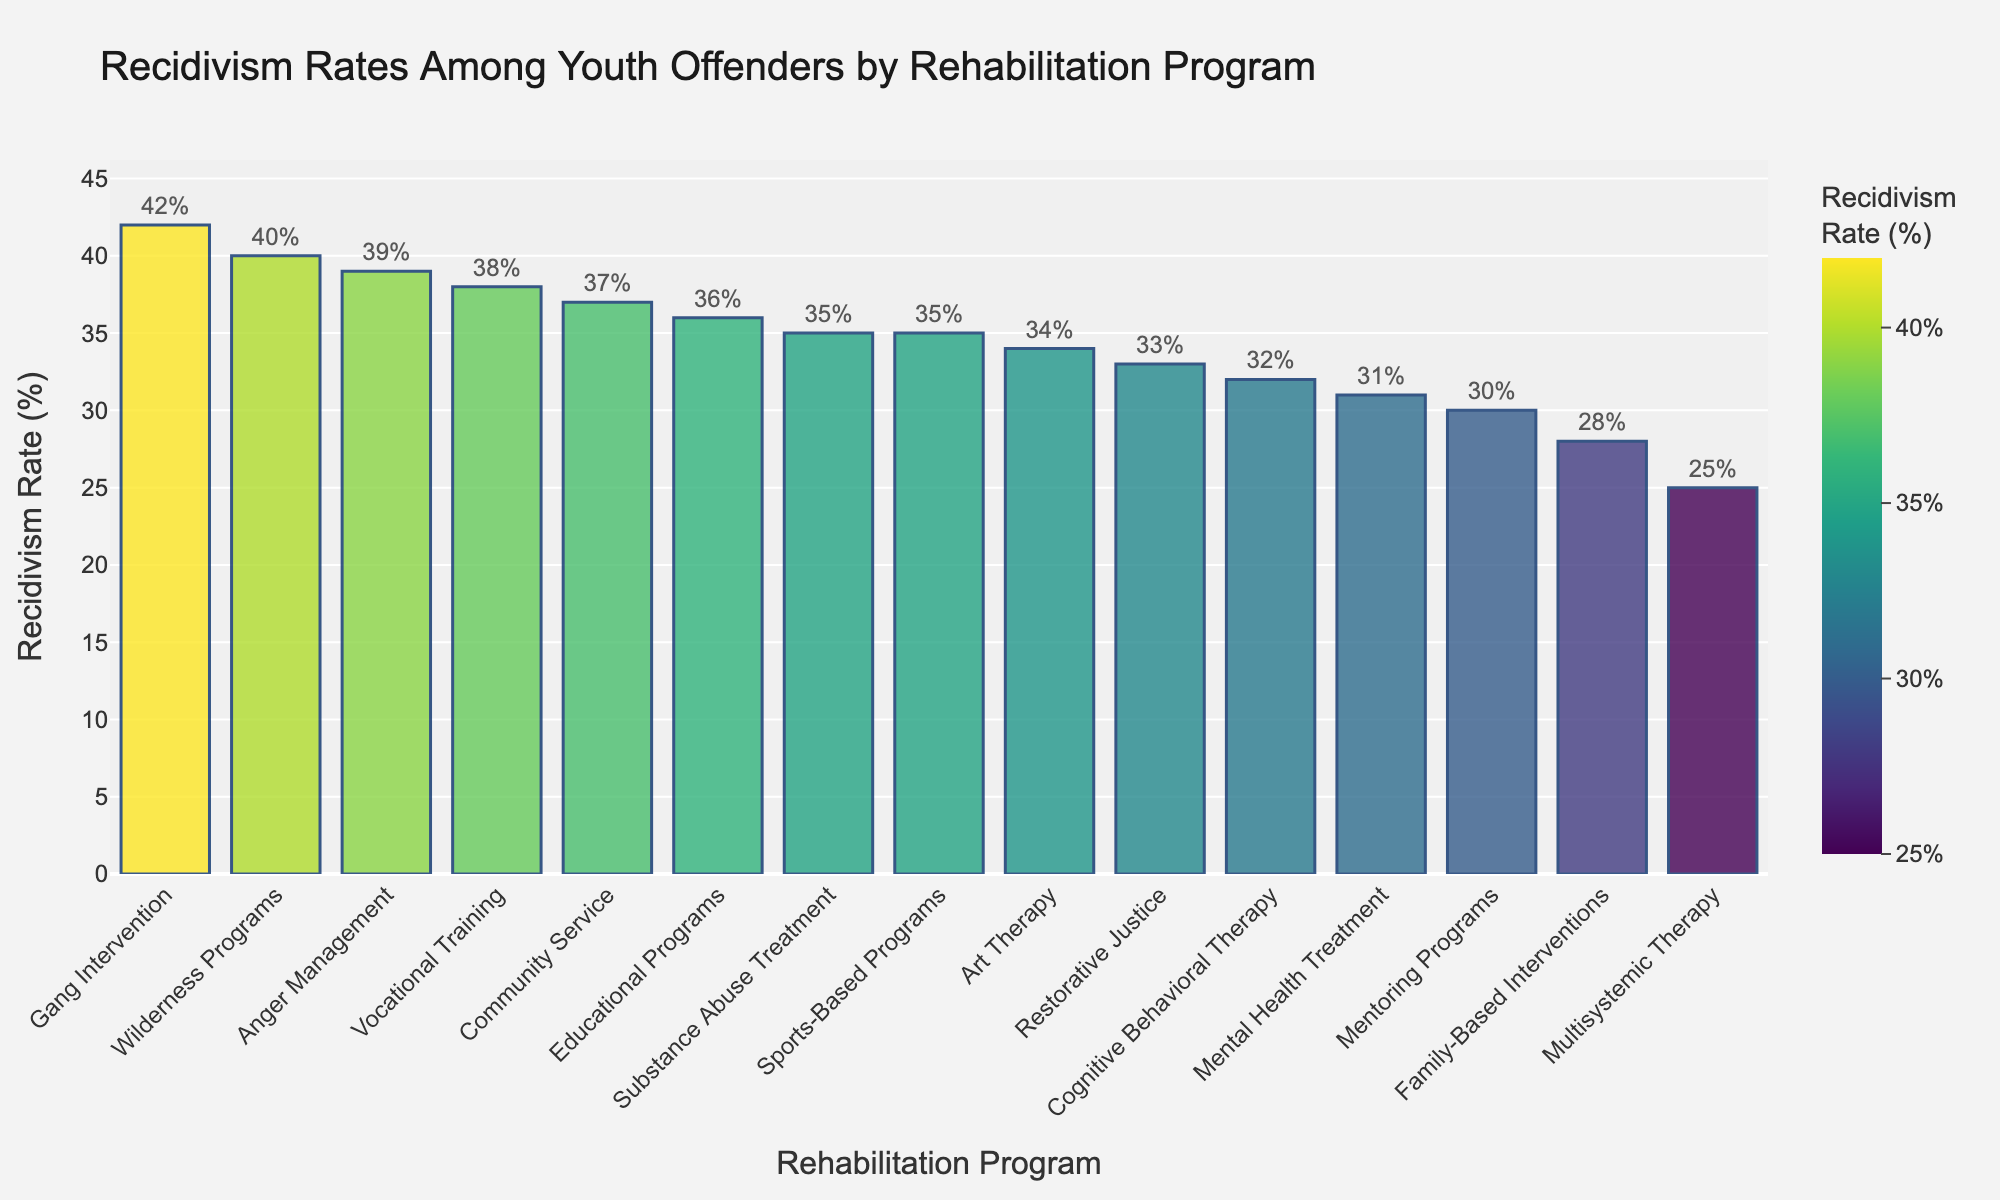What is the program with the highest recidivism rate? Look for the tallest bar in the chart. The tallest bar represents the program with the highest rate, which is 42%. The program type corresponding to this rate is "Gang Intervention".
Answer: Gang Intervention Which rehabilitation program has a lower recidivism rate: Cognitive Behavioral Therapy or Restorative Justice? Identify the bars for Cognitive Behavioral Therapy and Restorative Justice. Cognitive Behavioral Therapy has a recidivism rate of 32%, and Restorative Justice has a rate of 33%. Compare the heights of these bars to determine which is shorter.
Answer: Cognitive Behavioral Therapy What is the median recidivism rate of all the programs? Order the recidivism rates from lowest to highest and find the middle value: 25, 28, 30, 31, 32, 33, 34, 35, 35, 36, 37, 38, 39, 40, 42. The median value, being the 8th value in the sorted list, is 35%.
Answer: 35% Which program types have recidivism rates greater than 35%? Identify all bars with a value higher than 35%. The programs corresponding to these bars are Vocational Training (38%), Substance Abuse Treatment (35%), Wilderness Programs (40%), Anger Management (39%), Community Service (37%), and Gang Intervention (42%).
Answer: Vocational Training, Wilderness Programs, Anger Management, Community Service, Gang Intervention What is the difference in recidivism rates between Multisystemic Therapy and Educational Programs? Find the bars for Multisystemic Therapy and Educational Programs. Multisystemic Therapy has a rate of 25% and Educational Programs have 36%. Subtract the smaller rate from the larger one: 36% - 25% = 11%.
Answer: 11% How many programs have recidivism rates less than 30%? Count the number of bars with values below 30%. The programs with rates below 30% are Multisystemic Therapy (25%), Family-Based Interventions (28%), and Cognitive Behavioral Therapy (32%). The count is three programs.
Answer: 3 programs Which program has a recidivism rate closest to the average rate of all programs? Calculate the average by dividing the sum of all recidivism rates by the number of programs. The sum of the rates is 535%, and with 15 programs, the average is 535% / 15 = 35.67%. The closest rate is 35%, shared by Substance Abuse Treatment and Sports-Based Programs.
Answer: Substance Abuse Treatment, Sports-Based Programs What is the sum of the recidivism rates for the two programs with the lowest rates? Identify the two lowest bars, which are Multisystemic Therapy (25%) and Family-Based Interventions (28%). Add them together: 25% + 28% = 53%.
Answer: 53% How many programs have a recidivism rate between 30% and 40%? Count the number of bars with values between 30% and 40% (inclusive). These programs are Cognitive Behavioral Therapy (32%), Family-Based Interventions (28%), Restorative Justice (33%), Mentoring Programs (30%), Mental Health Treatment (31%), Art Therapy (34%), Sports-Based Programs (35%), Educational Programs (36%), Community Service (37%), Vocational Training (38%), and Anger Management (39%). The count is eleven programs.
Answer: 11 programs Which program type has a recidivism rate exactly equal to the median rate? Identify the median rate (35%). The programs with this rate are Substance Abuse Treatment, Sports-Based Programs.
Answer: Substance Abuse Treatment, Sports-Based Programs 